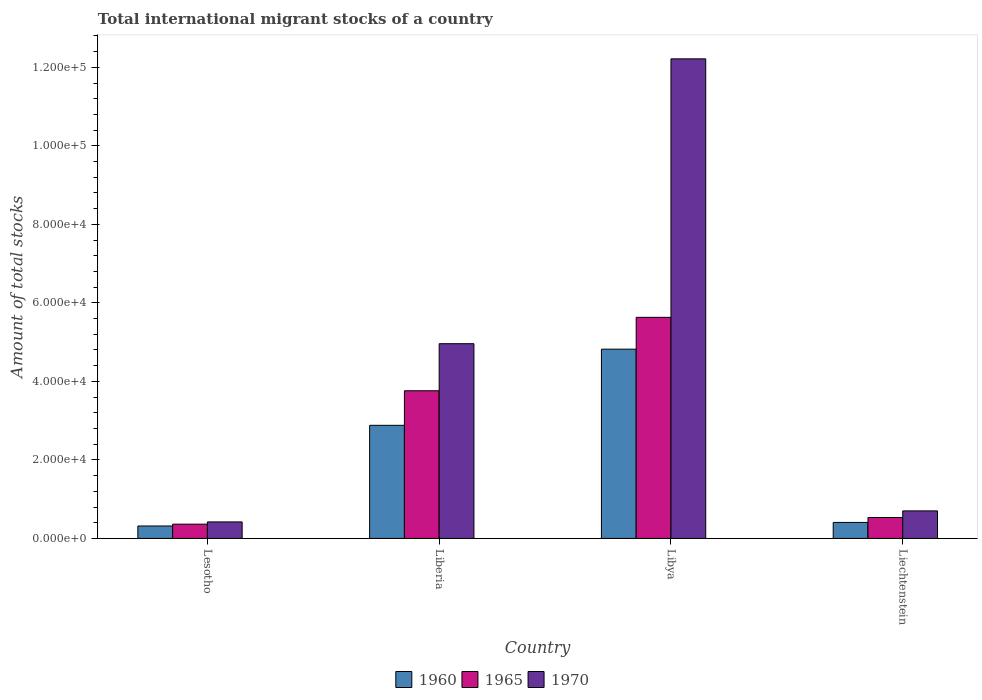How many different coloured bars are there?
Keep it short and to the point. 3. Are the number of bars on each tick of the X-axis equal?
Your answer should be compact. Yes. How many bars are there on the 1st tick from the left?
Your response must be concise. 3. How many bars are there on the 1st tick from the right?
Provide a short and direct response. 3. What is the label of the 4th group of bars from the left?
Give a very brief answer. Liechtenstein. In how many cases, is the number of bars for a given country not equal to the number of legend labels?
Ensure brevity in your answer.  0. What is the amount of total stocks in in 1960 in Liberia?
Offer a very short reply. 2.88e+04. Across all countries, what is the maximum amount of total stocks in in 1970?
Your answer should be compact. 1.22e+05. Across all countries, what is the minimum amount of total stocks in in 1970?
Your answer should be very brief. 4205. In which country was the amount of total stocks in in 1960 maximum?
Your response must be concise. Libya. In which country was the amount of total stocks in in 1965 minimum?
Offer a very short reply. Lesotho. What is the total amount of total stocks in in 1960 in the graph?
Provide a succinct answer. 8.43e+04. What is the difference between the amount of total stocks in in 1970 in Libya and that in Liechtenstein?
Keep it short and to the point. 1.15e+05. What is the difference between the amount of total stocks in in 1970 in Liechtenstein and the amount of total stocks in in 1965 in Lesotho?
Make the answer very short. 3379. What is the average amount of total stocks in in 1960 per country?
Offer a very short reply. 2.11e+04. What is the difference between the amount of total stocks in of/in 1965 and amount of total stocks in of/in 1970 in Libya?
Keep it short and to the point. -6.58e+04. What is the ratio of the amount of total stocks in in 1965 in Liberia to that in Liechtenstein?
Provide a succinct answer. 7.06. Is the amount of total stocks in in 1970 in Lesotho less than that in Liberia?
Provide a short and direct response. Yes. Is the difference between the amount of total stocks in in 1965 in Libya and Liechtenstein greater than the difference between the amount of total stocks in in 1970 in Libya and Liechtenstein?
Give a very brief answer. No. What is the difference between the highest and the second highest amount of total stocks in in 1965?
Offer a very short reply. 1.87e+04. What is the difference between the highest and the lowest amount of total stocks in in 1960?
Ensure brevity in your answer.  4.50e+04. What does the 1st bar from the left in Liberia represents?
Give a very brief answer. 1960. Is it the case that in every country, the sum of the amount of total stocks in in 1965 and amount of total stocks in in 1970 is greater than the amount of total stocks in in 1960?
Offer a very short reply. Yes. How many bars are there?
Offer a very short reply. 12. How many countries are there in the graph?
Give a very brief answer. 4. Are the values on the major ticks of Y-axis written in scientific E-notation?
Offer a very short reply. Yes. Does the graph contain grids?
Provide a short and direct response. No. What is the title of the graph?
Keep it short and to the point. Total international migrant stocks of a country. What is the label or title of the Y-axis?
Give a very brief answer. Amount of total stocks. What is the Amount of total stocks in 1960 in Lesotho?
Give a very brief answer. 3165. What is the Amount of total stocks in 1965 in Lesotho?
Ensure brevity in your answer.  3633. What is the Amount of total stocks in 1970 in Lesotho?
Make the answer very short. 4205. What is the Amount of total stocks of 1960 in Liberia?
Your answer should be very brief. 2.88e+04. What is the Amount of total stocks in 1965 in Liberia?
Make the answer very short. 3.76e+04. What is the Amount of total stocks of 1970 in Liberia?
Ensure brevity in your answer.  4.96e+04. What is the Amount of total stocks in 1960 in Libya?
Keep it short and to the point. 4.82e+04. What is the Amount of total stocks in 1965 in Libya?
Provide a succinct answer. 5.63e+04. What is the Amount of total stocks of 1970 in Libya?
Ensure brevity in your answer.  1.22e+05. What is the Amount of total stocks in 1960 in Liechtenstein?
Offer a terse response. 4070. What is the Amount of total stocks of 1965 in Liechtenstein?
Provide a short and direct response. 5328. What is the Amount of total stocks of 1970 in Liechtenstein?
Keep it short and to the point. 7012. Across all countries, what is the maximum Amount of total stocks in 1960?
Provide a succinct answer. 4.82e+04. Across all countries, what is the maximum Amount of total stocks of 1965?
Your response must be concise. 5.63e+04. Across all countries, what is the maximum Amount of total stocks in 1970?
Keep it short and to the point. 1.22e+05. Across all countries, what is the minimum Amount of total stocks in 1960?
Offer a terse response. 3165. Across all countries, what is the minimum Amount of total stocks in 1965?
Your answer should be very brief. 3633. Across all countries, what is the minimum Amount of total stocks of 1970?
Provide a short and direct response. 4205. What is the total Amount of total stocks of 1960 in the graph?
Your answer should be compact. 8.43e+04. What is the total Amount of total stocks in 1965 in the graph?
Provide a succinct answer. 1.03e+05. What is the total Amount of total stocks in 1970 in the graph?
Ensure brevity in your answer.  1.83e+05. What is the difference between the Amount of total stocks of 1960 in Lesotho and that in Liberia?
Provide a short and direct response. -2.56e+04. What is the difference between the Amount of total stocks in 1965 in Lesotho and that in Liberia?
Your answer should be very brief. -3.40e+04. What is the difference between the Amount of total stocks of 1970 in Lesotho and that in Liberia?
Ensure brevity in your answer.  -4.54e+04. What is the difference between the Amount of total stocks of 1960 in Lesotho and that in Libya?
Your answer should be compact. -4.50e+04. What is the difference between the Amount of total stocks in 1965 in Lesotho and that in Libya?
Offer a very short reply. -5.27e+04. What is the difference between the Amount of total stocks of 1970 in Lesotho and that in Libya?
Give a very brief answer. -1.18e+05. What is the difference between the Amount of total stocks of 1960 in Lesotho and that in Liechtenstein?
Give a very brief answer. -905. What is the difference between the Amount of total stocks in 1965 in Lesotho and that in Liechtenstein?
Your response must be concise. -1695. What is the difference between the Amount of total stocks in 1970 in Lesotho and that in Liechtenstein?
Provide a short and direct response. -2807. What is the difference between the Amount of total stocks in 1960 in Liberia and that in Libya?
Make the answer very short. -1.94e+04. What is the difference between the Amount of total stocks in 1965 in Liberia and that in Libya?
Provide a short and direct response. -1.87e+04. What is the difference between the Amount of total stocks of 1970 in Liberia and that in Libya?
Offer a terse response. -7.26e+04. What is the difference between the Amount of total stocks of 1960 in Liberia and that in Liechtenstein?
Provide a short and direct response. 2.47e+04. What is the difference between the Amount of total stocks in 1965 in Liberia and that in Liechtenstein?
Offer a terse response. 3.23e+04. What is the difference between the Amount of total stocks of 1970 in Liberia and that in Liechtenstein?
Your answer should be compact. 4.26e+04. What is the difference between the Amount of total stocks in 1960 in Libya and that in Liechtenstein?
Your answer should be compact. 4.41e+04. What is the difference between the Amount of total stocks of 1965 in Libya and that in Liechtenstein?
Your response must be concise. 5.10e+04. What is the difference between the Amount of total stocks in 1970 in Libya and that in Liechtenstein?
Your response must be concise. 1.15e+05. What is the difference between the Amount of total stocks of 1960 in Lesotho and the Amount of total stocks of 1965 in Liberia?
Offer a very short reply. -3.44e+04. What is the difference between the Amount of total stocks of 1960 in Lesotho and the Amount of total stocks of 1970 in Liberia?
Provide a succinct answer. -4.64e+04. What is the difference between the Amount of total stocks in 1965 in Lesotho and the Amount of total stocks in 1970 in Liberia?
Your answer should be very brief. -4.60e+04. What is the difference between the Amount of total stocks of 1960 in Lesotho and the Amount of total stocks of 1965 in Libya?
Give a very brief answer. -5.32e+04. What is the difference between the Amount of total stocks in 1960 in Lesotho and the Amount of total stocks in 1970 in Libya?
Your answer should be very brief. -1.19e+05. What is the difference between the Amount of total stocks in 1965 in Lesotho and the Amount of total stocks in 1970 in Libya?
Give a very brief answer. -1.19e+05. What is the difference between the Amount of total stocks of 1960 in Lesotho and the Amount of total stocks of 1965 in Liechtenstein?
Provide a short and direct response. -2163. What is the difference between the Amount of total stocks of 1960 in Lesotho and the Amount of total stocks of 1970 in Liechtenstein?
Keep it short and to the point. -3847. What is the difference between the Amount of total stocks of 1965 in Lesotho and the Amount of total stocks of 1970 in Liechtenstein?
Offer a very short reply. -3379. What is the difference between the Amount of total stocks of 1960 in Liberia and the Amount of total stocks of 1965 in Libya?
Offer a very short reply. -2.75e+04. What is the difference between the Amount of total stocks in 1960 in Liberia and the Amount of total stocks in 1970 in Libya?
Give a very brief answer. -9.34e+04. What is the difference between the Amount of total stocks in 1965 in Liberia and the Amount of total stocks in 1970 in Libya?
Offer a terse response. -8.46e+04. What is the difference between the Amount of total stocks in 1960 in Liberia and the Amount of total stocks in 1965 in Liechtenstein?
Give a very brief answer. 2.35e+04. What is the difference between the Amount of total stocks in 1960 in Liberia and the Amount of total stocks in 1970 in Liechtenstein?
Keep it short and to the point. 2.18e+04. What is the difference between the Amount of total stocks in 1965 in Liberia and the Amount of total stocks in 1970 in Liechtenstein?
Give a very brief answer. 3.06e+04. What is the difference between the Amount of total stocks in 1960 in Libya and the Amount of total stocks in 1965 in Liechtenstein?
Give a very brief answer. 4.29e+04. What is the difference between the Amount of total stocks in 1960 in Libya and the Amount of total stocks in 1970 in Liechtenstein?
Give a very brief answer. 4.12e+04. What is the difference between the Amount of total stocks in 1965 in Libya and the Amount of total stocks in 1970 in Liechtenstein?
Your answer should be compact. 4.93e+04. What is the average Amount of total stocks of 1960 per country?
Your answer should be very brief. 2.11e+04. What is the average Amount of total stocks of 1965 per country?
Provide a short and direct response. 2.57e+04. What is the average Amount of total stocks of 1970 per country?
Keep it short and to the point. 4.57e+04. What is the difference between the Amount of total stocks in 1960 and Amount of total stocks in 1965 in Lesotho?
Provide a short and direct response. -468. What is the difference between the Amount of total stocks in 1960 and Amount of total stocks in 1970 in Lesotho?
Your answer should be compact. -1040. What is the difference between the Amount of total stocks of 1965 and Amount of total stocks of 1970 in Lesotho?
Provide a short and direct response. -572. What is the difference between the Amount of total stocks of 1960 and Amount of total stocks of 1965 in Liberia?
Your answer should be very brief. -8803. What is the difference between the Amount of total stocks in 1960 and Amount of total stocks in 1970 in Liberia?
Your answer should be compact. -2.08e+04. What is the difference between the Amount of total stocks in 1965 and Amount of total stocks in 1970 in Liberia?
Your response must be concise. -1.20e+04. What is the difference between the Amount of total stocks in 1960 and Amount of total stocks in 1965 in Libya?
Keep it short and to the point. -8110. What is the difference between the Amount of total stocks of 1960 and Amount of total stocks of 1970 in Libya?
Provide a short and direct response. -7.40e+04. What is the difference between the Amount of total stocks of 1965 and Amount of total stocks of 1970 in Libya?
Your answer should be very brief. -6.58e+04. What is the difference between the Amount of total stocks of 1960 and Amount of total stocks of 1965 in Liechtenstein?
Provide a short and direct response. -1258. What is the difference between the Amount of total stocks of 1960 and Amount of total stocks of 1970 in Liechtenstein?
Keep it short and to the point. -2942. What is the difference between the Amount of total stocks in 1965 and Amount of total stocks in 1970 in Liechtenstein?
Offer a terse response. -1684. What is the ratio of the Amount of total stocks of 1960 in Lesotho to that in Liberia?
Give a very brief answer. 0.11. What is the ratio of the Amount of total stocks of 1965 in Lesotho to that in Liberia?
Give a very brief answer. 0.1. What is the ratio of the Amount of total stocks of 1970 in Lesotho to that in Liberia?
Make the answer very short. 0.08. What is the ratio of the Amount of total stocks of 1960 in Lesotho to that in Libya?
Offer a terse response. 0.07. What is the ratio of the Amount of total stocks in 1965 in Lesotho to that in Libya?
Offer a very short reply. 0.06. What is the ratio of the Amount of total stocks in 1970 in Lesotho to that in Libya?
Keep it short and to the point. 0.03. What is the ratio of the Amount of total stocks in 1960 in Lesotho to that in Liechtenstein?
Keep it short and to the point. 0.78. What is the ratio of the Amount of total stocks of 1965 in Lesotho to that in Liechtenstein?
Offer a very short reply. 0.68. What is the ratio of the Amount of total stocks of 1970 in Lesotho to that in Liechtenstein?
Offer a terse response. 0.6. What is the ratio of the Amount of total stocks of 1960 in Liberia to that in Libya?
Offer a very short reply. 0.6. What is the ratio of the Amount of total stocks in 1965 in Liberia to that in Libya?
Offer a terse response. 0.67. What is the ratio of the Amount of total stocks of 1970 in Liberia to that in Libya?
Your answer should be compact. 0.41. What is the ratio of the Amount of total stocks in 1960 in Liberia to that in Liechtenstein?
Your answer should be compact. 7.08. What is the ratio of the Amount of total stocks of 1965 in Liberia to that in Liechtenstein?
Your answer should be compact. 7.06. What is the ratio of the Amount of total stocks of 1970 in Liberia to that in Liechtenstein?
Your answer should be compact. 7.07. What is the ratio of the Amount of total stocks in 1960 in Libya to that in Liechtenstein?
Make the answer very short. 11.85. What is the ratio of the Amount of total stocks of 1965 in Libya to that in Liechtenstein?
Your response must be concise. 10.57. What is the ratio of the Amount of total stocks in 1970 in Libya to that in Liechtenstein?
Your answer should be compact. 17.42. What is the difference between the highest and the second highest Amount of total stocks of 1960?
Your answer should be compact. 1.94e+04. What is the difference between the highest and the second highest Amount of total stocks of 1965?
Make the answer very short. 1.87e+04. What is the difference between the highest and the second highest Amount of total stocks of 1970?
Provide a succinct answer. 7.26e+04. What is the difference between the highest and the lowest Amount of total stocks in 1960?
Your response must be concise. 4.50e+04. What is the difference between the highest and the lowest Amount of total stocks of 1965?
Provide a succinct answer. 5.27e+04. What is the difference between the highest and the lowest Amount of total stocks in 1970?
Keep it short and to the point. 1.18e+05. 